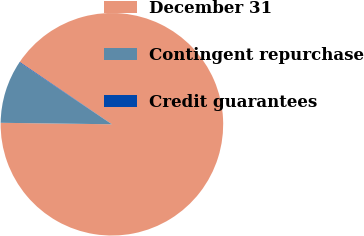<chart> <loc_0><loc_0><loc_500><loc_500><pie_chart><fcel>December 31<fcel>Contingent repurchase<fcel>Credit guarantees<nl><fcel>90.75%<fcel>9.16%<fcel>0.09%<nl></chart> 